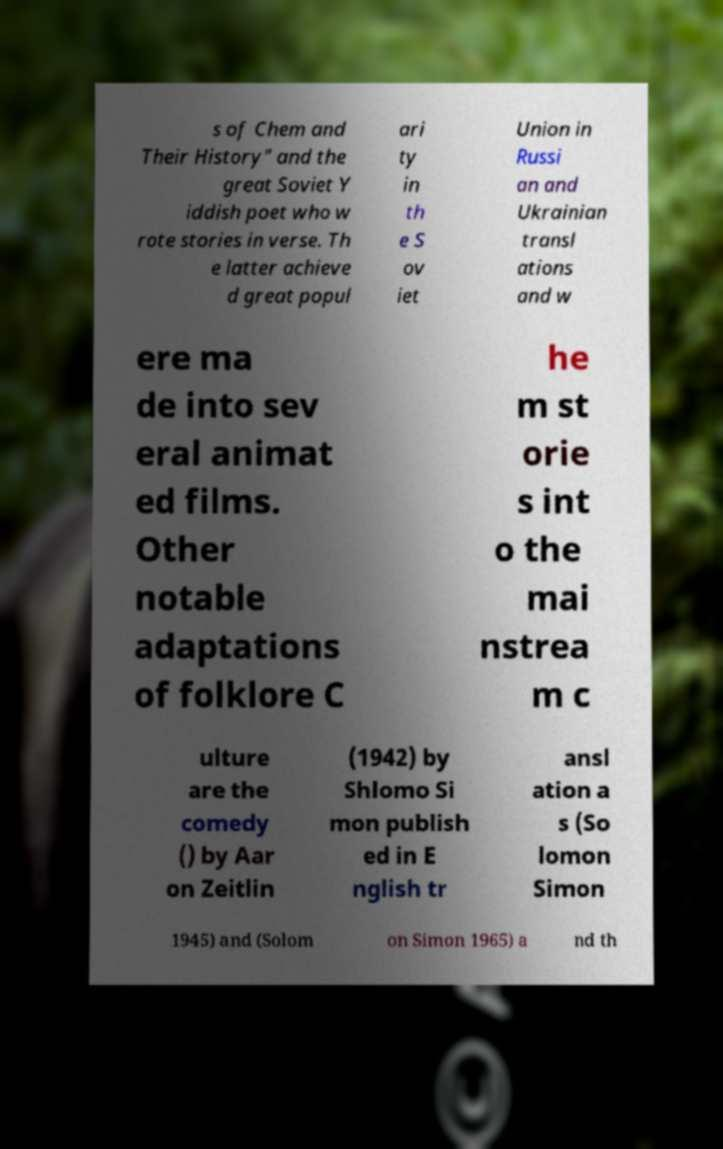Can you accurately transcribe the text from the provided image for me? s of Chem and Their History" and the great Soviet Y iddish poet who w rote stories in verse. Th e latter achieve d great popul ari ty in th e S ov iet Union in Russi an and Ukrainian transl ations and w ere ma de into sev eral animat ed films. Other notable adaptations of folklore C he m st orie s int o the mai nstrea m c ulture are the comedy () by Aar on Zeitlin (1942) by Shlomo Si mon publish ed in E nglish tr ansl ation a s (So lomon Simon 1945) and (Solom on Simon 1965) a nd th 